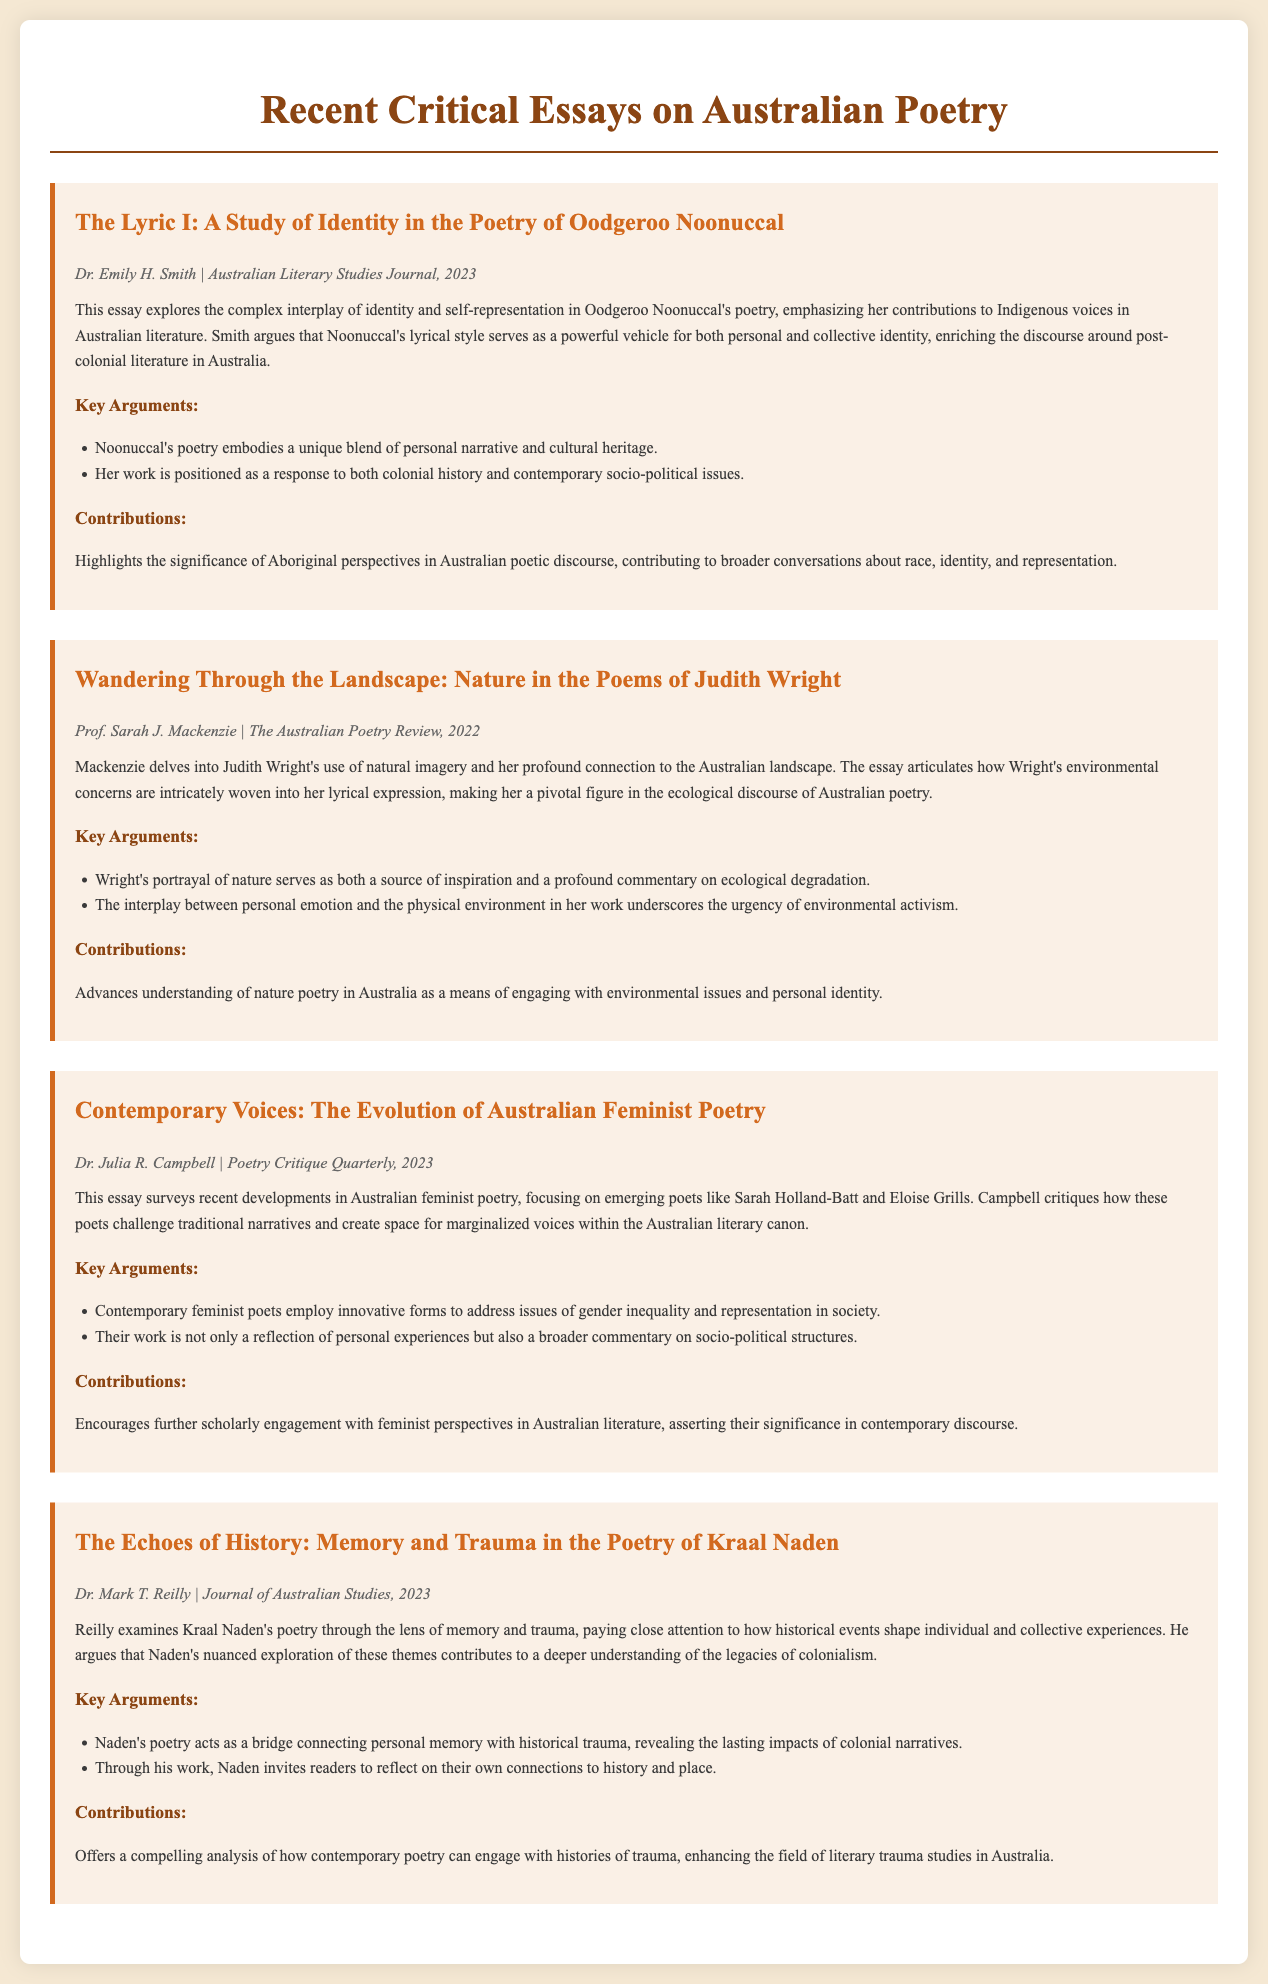What is the title of the essay by Dr. Emily H. Smith? The title is explicitly mentioned in the document under her name and the essay section.
Answer: The Lyric I: A Study of Identity in the Poetry of Oodgeroo Noonuccal Who authored the essay about Judith Wright? The author's name is given in the metadata section of the essay.
Answer: Prof. Sarah J. Mackenzie In what year was the essay on Australian feminist poetry published? The publication year is provided in the metadata of the essay.
Answer: 2023 What is the main theme discussed in Kraal Naden's poetry? The summary of the essay outlines the focus on memory and trauma in Naden's work.
Answer: Memory and trauma How does Dr. Mark T. Reilly characterize Kraal Naden's poetry? The summary clearly states how Reilly views Naden's contributions through thematic exploration.
Answer: A bridge connecting personal memory with historical trauma What significant contribution does the essay by Dr. Julia R. Campbell make? The contributions section describes the value of Campbell's work in expanding scholarly discussions.
Answer: Encourages further scholarly engagement with feminist perspectives in Australian literature Which poet's work is described as pivotal in the ecological discourse of Australian poetry? The summary of the essay on Judith Wright discusses her role in this context.
Answer: Judith Wright How many key arguments are presented in the essay about contemporary feminist poetry? The number of key arguments is indicated in the arguments section of the relevant essay.
Answer: Two 